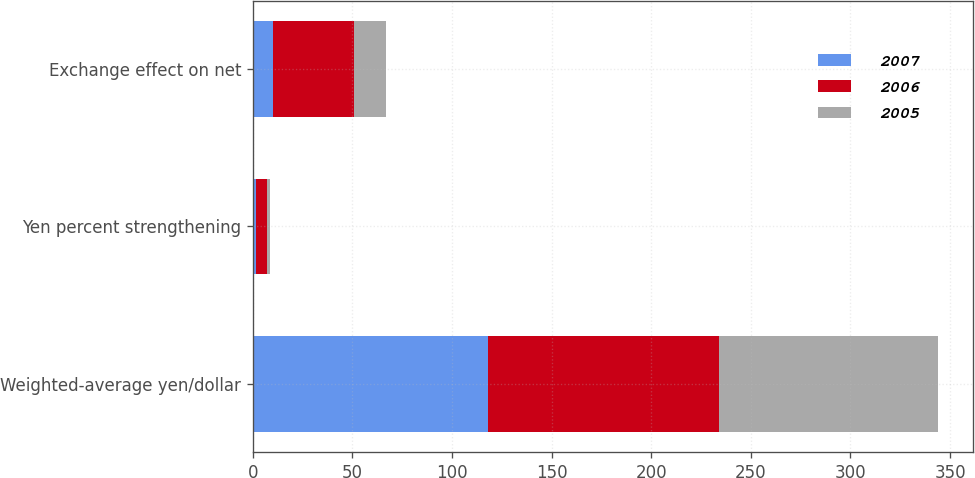Convert chart to OTSL. <chart><loc_0><loc_0><loc_500><loc_500><stacked_bar_chart><ecel><fcel>Weighted-average yen/dollar<fcel>Yen percent strengthening<fcel>Exchange effect on net<nl><fcel>2007<fcel>117.93<fcel>1.4<fcel>10<nl><fcel>2006<fcel>116.31<fcel>5.5<fcel>41<nl><fcel>2005<fcel>109.88<fcel>1.5<fcel>16<nl></chart> 